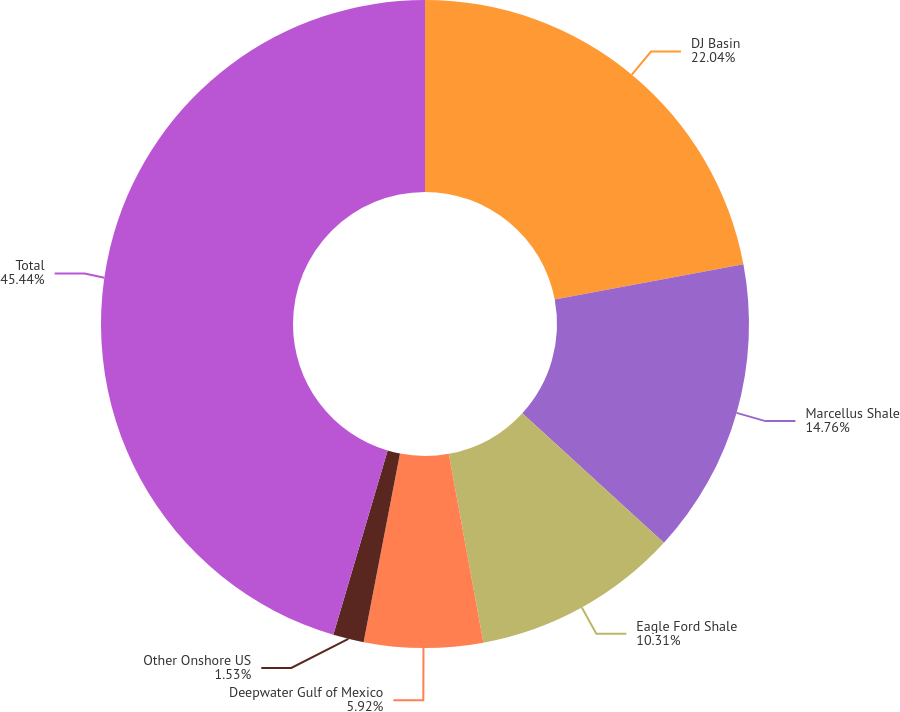Convert chart. <chart><loc_0><loc_0><loc_500><loc_500><pie_chart><fcel>DJ Basin<fcel>Marcellus Shale<fcel>Eagle Ford Shale<fcel>Deepwater Gulf of Mexico<fcel>Other Onshore US<fcel>Total<nl><fcel>22.04%<fcel>14.76%<fcel>10.31%<fcel>5.92%<fcel>1.53%<fcel>45.43%<nl></chart> 